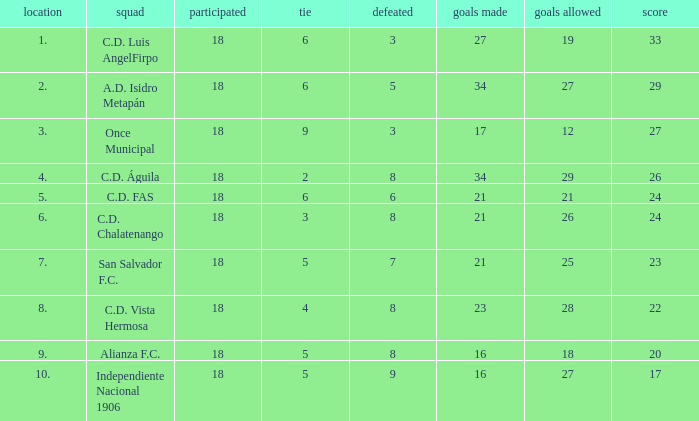What were the goal conceded that had a lost greater than 8 and more than 17 points? None. 